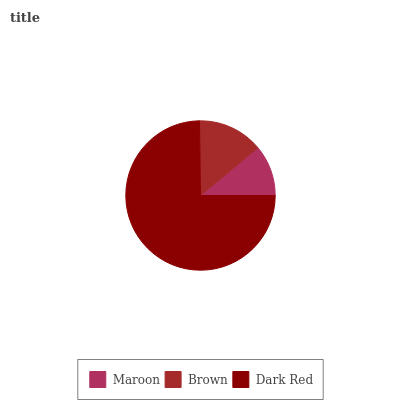Is Maroon the minimum?
Answer yes or no. Yes. Is Dark Red the maximum?
Answer yes or no. Yes. Is Brown the minimum?
Answer yes or no. No. Is Brown the maximum?
Answer yes or no. No. Is Brown greater than Maroon?
Answer yes or no. Yes. Is Maroon less than Brown?
Answer yes or no. Yes. Is Maroon greater than Brown?
Answer yes or no. No. Is Brown less than Maroon?
Answer yes or no. No. Is Brown the high median?
Answer yes or no. Yes. Is Brown the low median?
Answer yes or no. Yes. Is Maroon the high median?
Answer yes or no. No. Is Dark Red the low median?
Answer yes or no. No. 